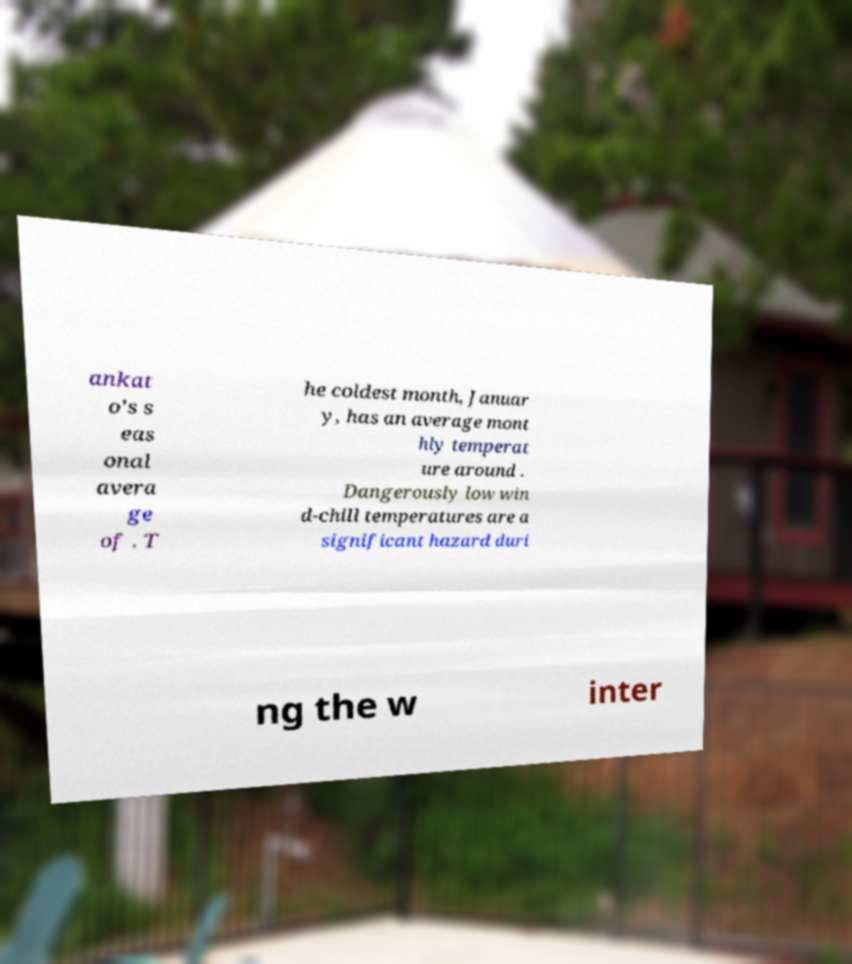Please read and relay the text visible in this image. What does it say? ankat o's s eas onal avera ge of . T he coldest month, Januar y, has an average mont hly temperat ure around . Dangerously low win d-chill temperatures are a significant hazard duri ng the w inter 